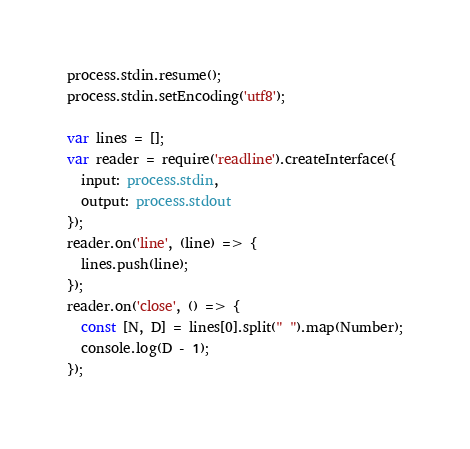<code> <loc_0><loc_0><loc_500><loc_500><_TypeScript_>process.stdin.resume();
process.stdin.setEncoding('utf8');

var lines = [];
var reader = require('readline').createInterface({
  input: process.stdin,
  output: process.stdout
});
reader.on('line', (line) => {
  lines.push(line);
});
reader.on('close', () => {
  const [N, D] = lines[0].split(" ").map(Number);
  console.log(D - 1);
});
</code> 